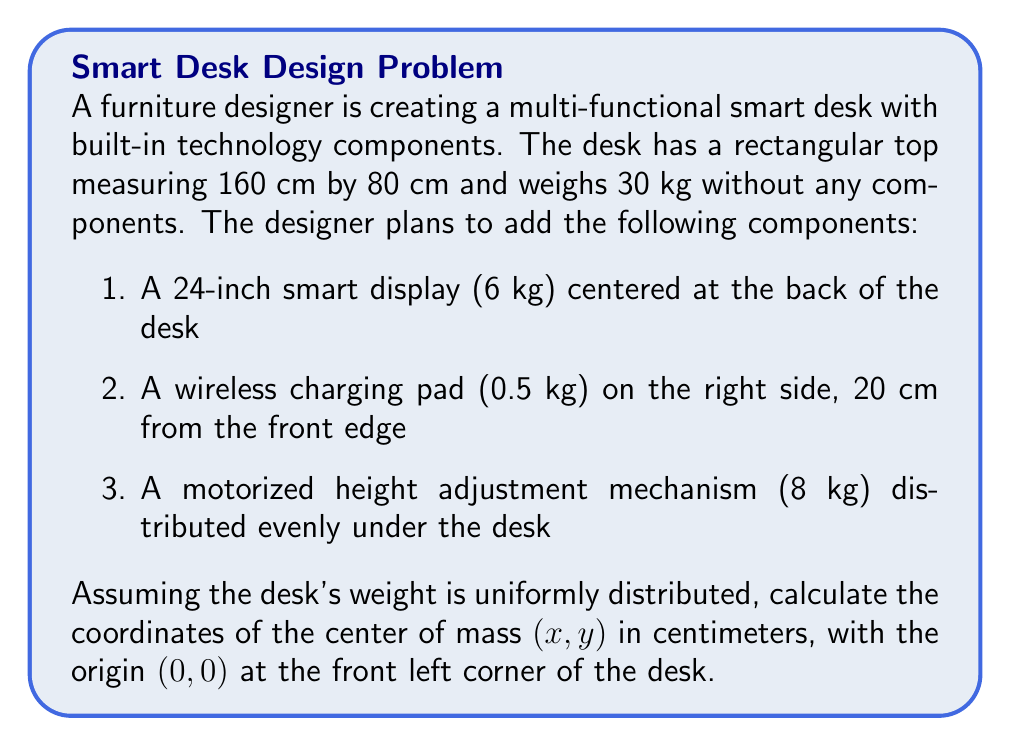Can you solve this math problem? To solve this problem, we need to calculate the weighted average of the x and y coordinates for all components, including the desk itself. We'll use the formula for the center of mass:

$$ x_{cm} = \frac{\sum m_i x_i}{\sum m_i} \quad \text{and} \quad y_{cm} = \frac{\sum m_i y_i}{\sum m_i} $$

Let's break down the calculation for each component:

1. Desk (30 kg):
   Center at (80 cm, 40 cm)
   $m_1 = 30$, $x_1 = 80$, $y_1 = 40$

2. Smart display (6 kg):
   Center at (80 cm, 80 cm)
   $m_2 = 6$, $x_2 = 80$, $y_2 = 80$

3. Wireless charging pad (0.5 kg):
   Center at (140 cm, 20 cm)
   $m_3 = 0.5$, $x_3 = 140$, $y_3 = 20$

4. Height adjustment mechanism (8 kg):
   Evenly distributed, so center remains at (80 cm, 40 cm)
   $m_4 = 8$, $x_4 = 80$, $y_4 = 40$

Total mass: $M = 30 + 6 + 0.5 + 8 = 44.5$ kg

Now, let's calculate the center of mass coordinates:

$$ x_{cm} = \frac{(30 \times 80) + (6 \times 80) + (0.5 \times 140) + (8 \times 80)}{44.5} = \frac{3550}{44.5} \approx 79.78 \text{ cm} $$

$$ y_{cm} = \frac{(30 \times 40) + (6 \times 80) + (0.5 \times 20) + (8 \times 40)}{44.5} = \frac{1890}{44.5} \approx 42.47 \text{ cm} $$
Answer: The center of mass of the multi-functional smart desk is located at approximately (79.78 cm, 42.47 cm) from the front left corner of the desk. 